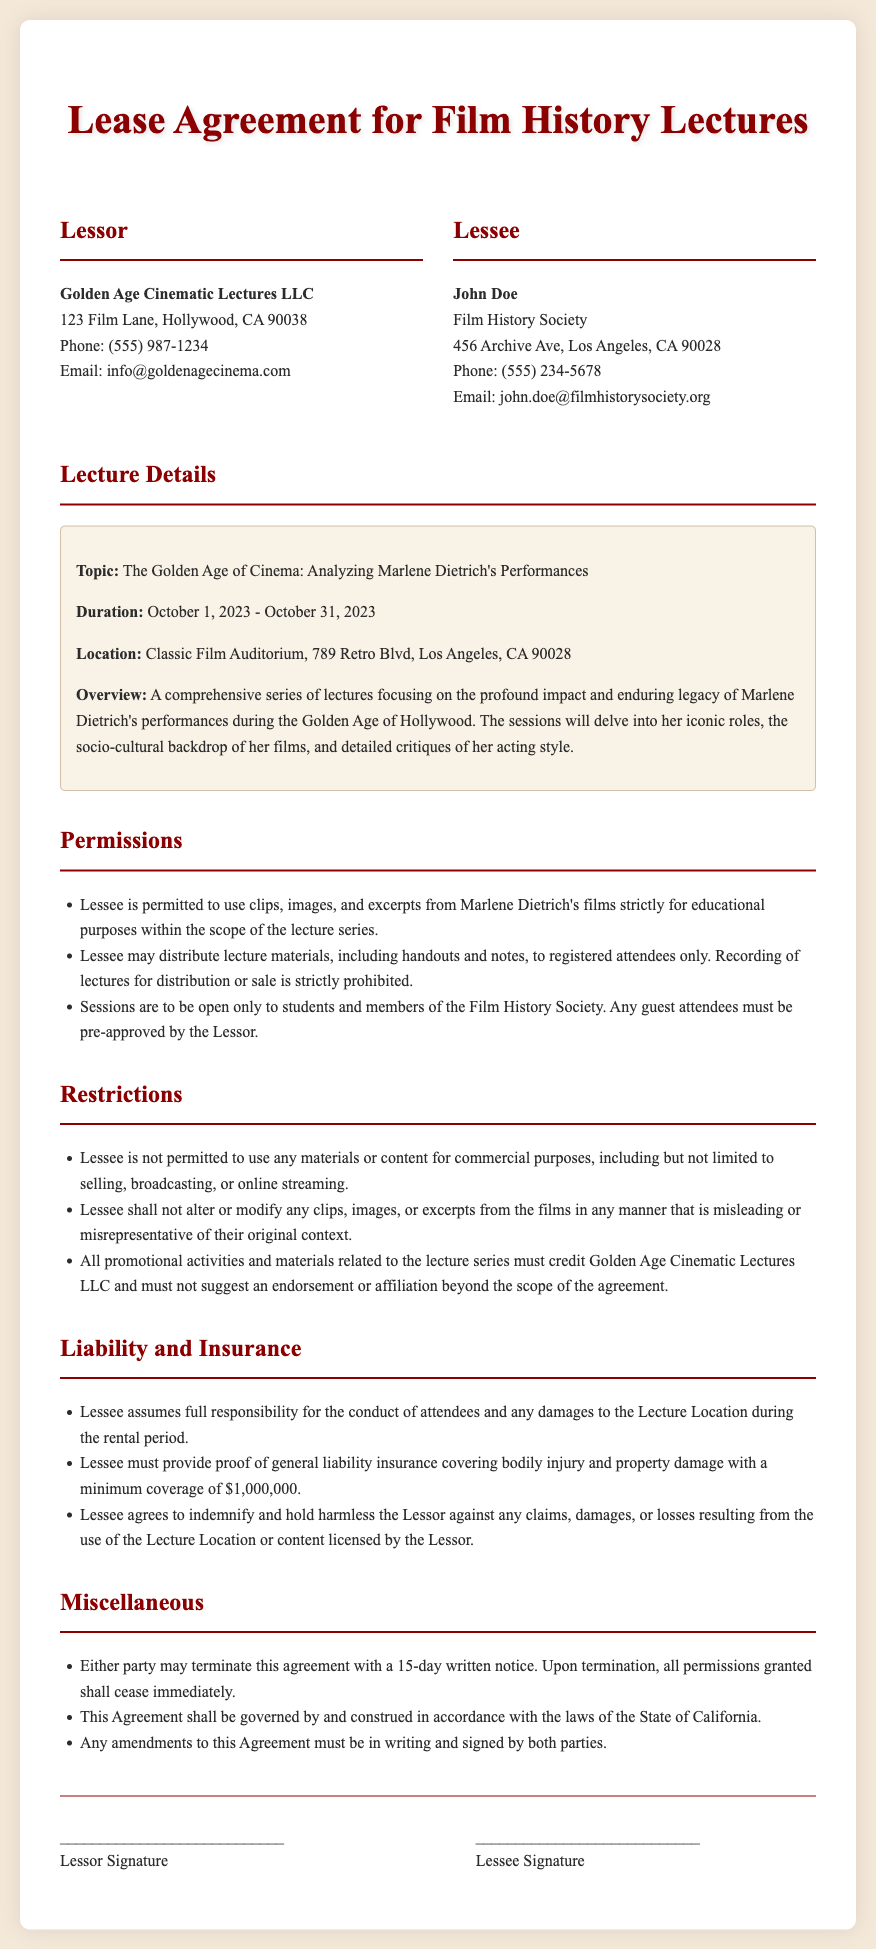What is the name of the lessor? The lessor is identified as Golden Age Cinematic Lectures LLC in the document.
Answer: Golden Age Cinematic Lectures LLC What is the lease duration? The lease duration is specified from October 1, 2023, to October 31, 2023.
Answer: October 1, 2023 - October 31, 2023 Where will the lectures be held? The location for the lectures is noted as Classic Film Auditorium, 789 Retro Blvd, Los Angeles, CA 90028.
Answer: Classic Film Auditorium, 789 Retro Blvd, Los Angeles, CA 90028 What is prohibited regarding the distribution of lectures? The document states that recording of lectures for distribution or sale is strictly prohibited.
Answer: Recording of lectures for distribution or sale Who must approve guest attendees? The document requires that any guest attendees must be pre-approved by the lessor.
Answer: Lessor What type of insurance is required? The lessee must provide proof of general liability insurance covering bodily injury and property damage.
Answer: General liability insurance 